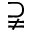Convert formula to latex. <formula><loc_0><loc_0><loc_500><loc_500>\supsetneqq</formula> 